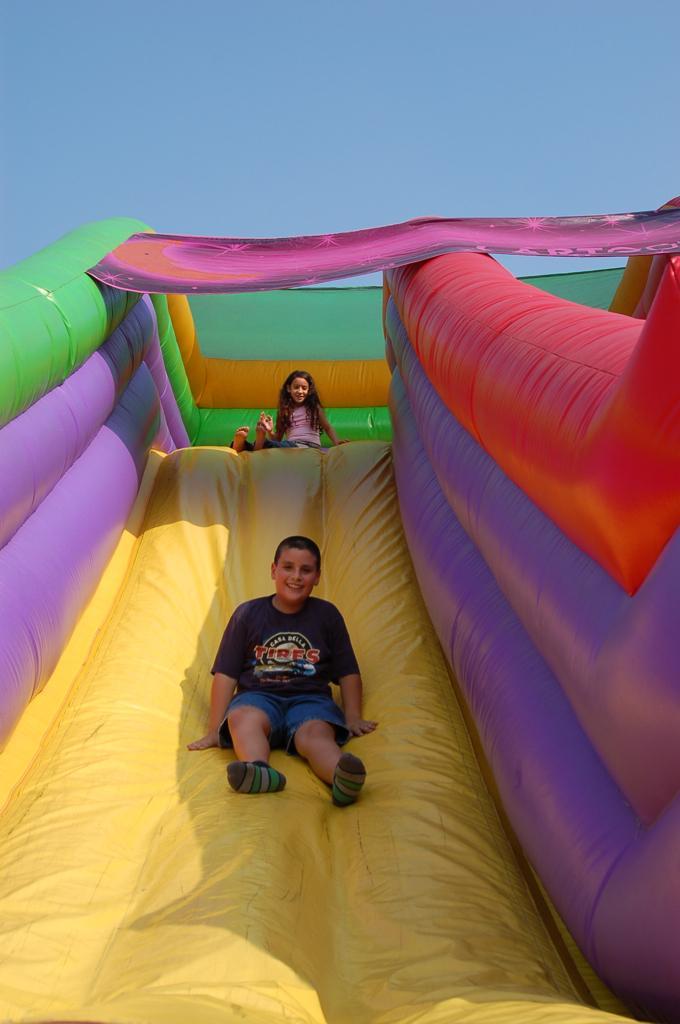Describe this image in one or two sentences. In this image, we can see two kids on garden slide. These two kids are wearing clothes. There is a sky at the top of the image. 